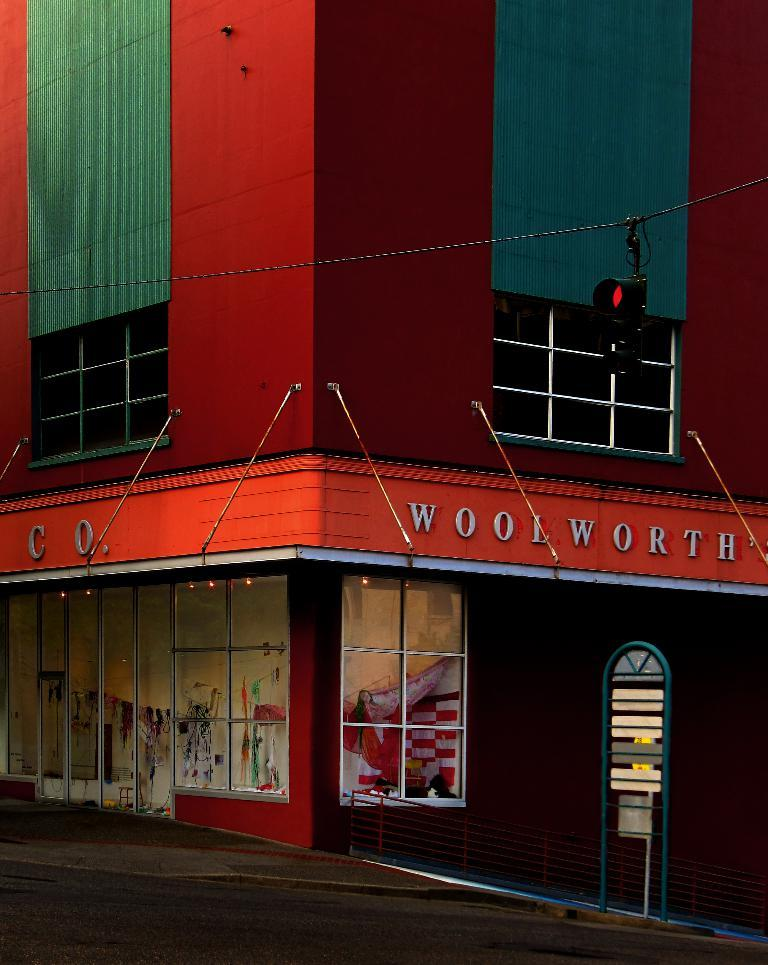What is the color of the building in the image? The building in the image is red-colored. What objects can be seen in the image besides the building? There are boards, clothes, a wire, a signal light, and text visible in the image. What might the boards be used for? The boards could be used for construction or signage. What is the purpose of the signal light in the image? The signal light is likely used for traffic control or safety purposes. Are there any dinosaurs visible in the image? No, there are no dinosaurs present in the image. Can you see any wounds on the clothes in the image? There is no indication of any wounds on the clothes in the image. 